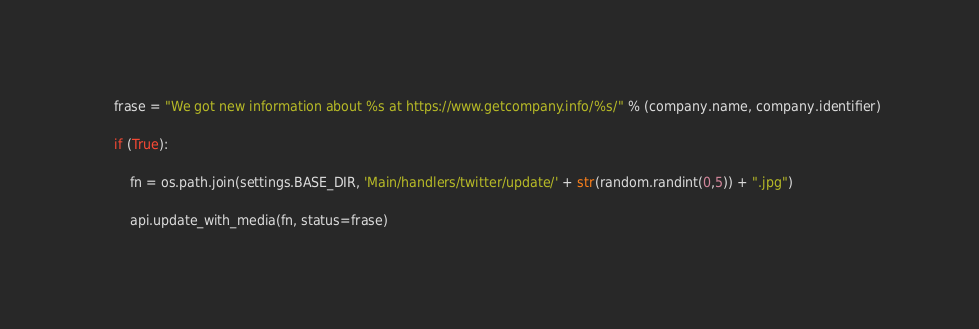<code> <loc_0><loc_0><loc_500><loc_500><_Python_>
    frase = "We got new information about %s at https://www.getcompany.info/%s/" % (company.name, company.identifier)

    if (True):

        fn = os.path.join(settings.BASE_DIR, 'Main/handlers/twitter/update/' + str(random.randint(0,5)) + ".jpg")

        api.update_with_media(fn, status=frase)</code> 